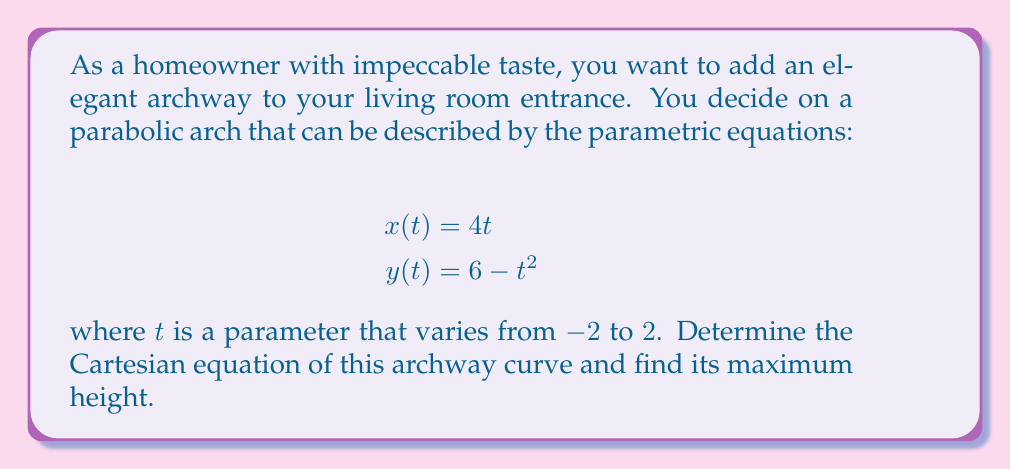Teach me how to tackle this problem. To solve this problem, we'll follow these steps:

1) First, we need to eliminate the parameter $t$ to find the Cartesian equation of the curve.

2) From the first equation, we can express $t$ in terms of $x$:
   $$t = \frac{x}{4}$$

3) Substitute this into the equation for $y$:
   $$y = 6 - (\frac{x}{4})^2$$

4) Simplify:
   $$y = 6 - \frac{x^2}{16}$$

5) This is the Cartesian equation of the parabolic arch.

6) To find the maximum height, we need to find the vertex of the parabola. The general form of a parabola is:
   $$y = a(x-h)^2 + k$$
   where $(h,k)$ is the vertex.

7) Our equation is already in the form:
   $$y = -\frac{1}{16}x^2 + 6$$

8) Comparing this to the general form, we can see that $h=0$ and $k=6$.

9) Therefore, the maximum height occurs at $x=0$ and is equal to 6.

[asy]
import graph;
size(200,200);
real f(real x) {return 6-x^2/16;}
draw(graph(f,-8,8),blue);
dot((0,6),red);
label("(0,6)",(0,6),N);
xaxis("x");
yaxis("y");
[/asy]
Answer: The Cartesian equation of the archway curve is $y = 6 - \frac{x^2}{16}$, and its maximum height is 6 units. 